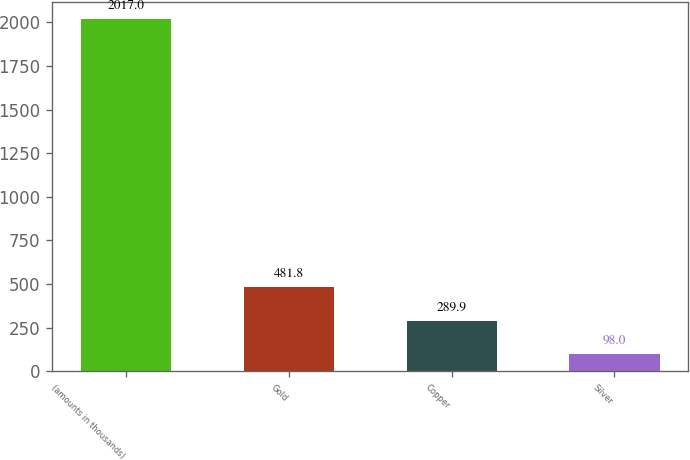Convert chart. <chart><loc_0><loc_0><loc_500><loc_500><bar_chart><fcel>(amounts in thousands)<fcel>Gold<fcel>Copper<fcel>Silver<nl><fcel>2017<fcel>481.8<fcel>289.9<fcel>98<nl></chart> 